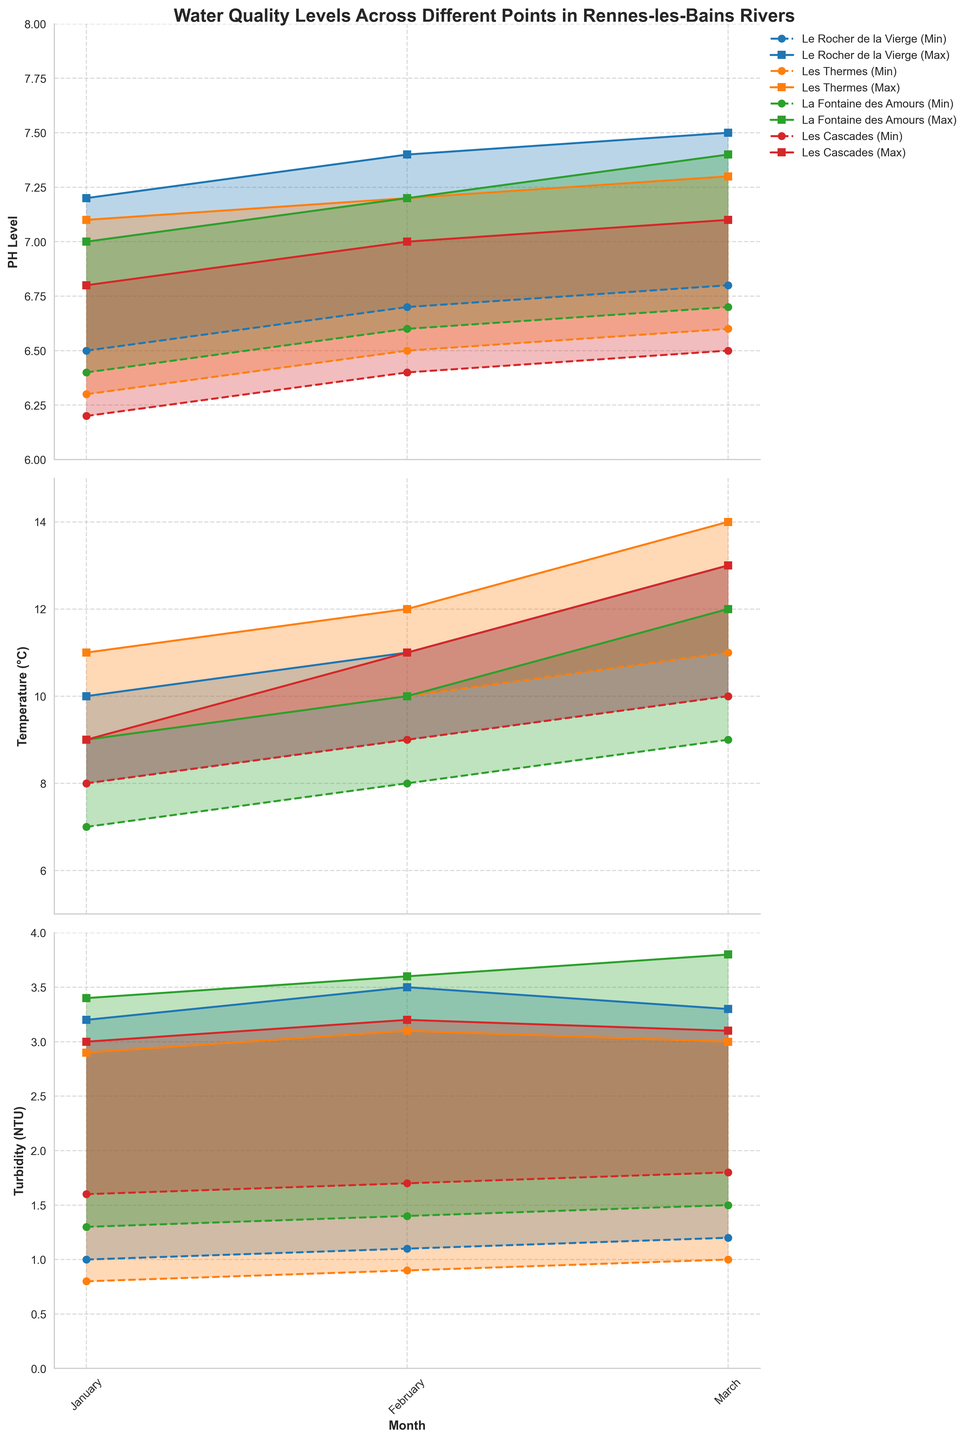What is the title of the figure? The title is usually located at the top of the figure and is written in larger, bold letters.
Answer: "Water Quality Levels Across Different Points in Rennes-les-Bains Rivers" What is the pH range for Le Rocher de la Vierge in March? To find the pH range, subtract the minimum pH level from the maximum pH level for Le Rocher de la Vierge in March: 7.5 - 6.8.
Answer: 0.7 Which location shows the highest maximum turbidity level in March? By comparing the maximum turbidity levels in March for all locations, La Fontaine des Amours has the highest value at 3.8 NTU.
Answer: La Fontaine des Amours How does the minimum temperature in February compare between Le Rocher de la Vierge and Les Cascades? Look at the minimum temperature for both locations in February: Le Rocher de la Vierge (9°C) and Les Cascades (9°C). Both are the same.
Answer: Equal What is the average maximum temperature in March across all locations? To find the average, sum the maximum temperatures in March for all locations and divide by the number of locations: (13+14+12+13)/4 = 52/4.
Answer: 13°C What is the difference between the maximum and minimum pH levels for Les Thermes in January? Subtract the minimum pH level from the maximum pH level for Les Thermes in January: 7.1 - 6.3.
Answer: 0.8 Which location shows the smallest variation in turbidity in January? To find the smallest variation in turbidity, subtract the minimum turbidity value from the maximum for each location in January and compare: Le Rocher de la Vierge (3.2-1.0=2.2), Les Thermes (2.9-0.8=2.1), La Fontaine des Amours (3.4-1.3=2.1), Les Cascades (3.0-1.6=1.4). Les Cascades shows the smallest variation.
Answer: Les Cascades What is the trend in maximum pH levels over the months for Les Thermes? Look at the maximum pH levels for Les Thermes in January, February, and March: 7.1, 7.2, 7.3. The trend shows a gradual increase over the months.
Answer: Increasing Between February and March, which location shows the largest increase in maximum temperature? Calculate the increase in maximum temperature from February to March for each location and compare: Le Rocher de la Vierge (13-11=2), Les Thermes (14-12=2), La Fontaine des Amours (12-10=2), Les Cascades (13-11=2). They all show the same increase.
Answer: All locations show the same increase What is the highest minimum pH level observed across all locations and months? Look at all the minimum pH levels and identify the highest: 6.8 (Le Rocher de la Vierge in March).
Answer: 6.8 